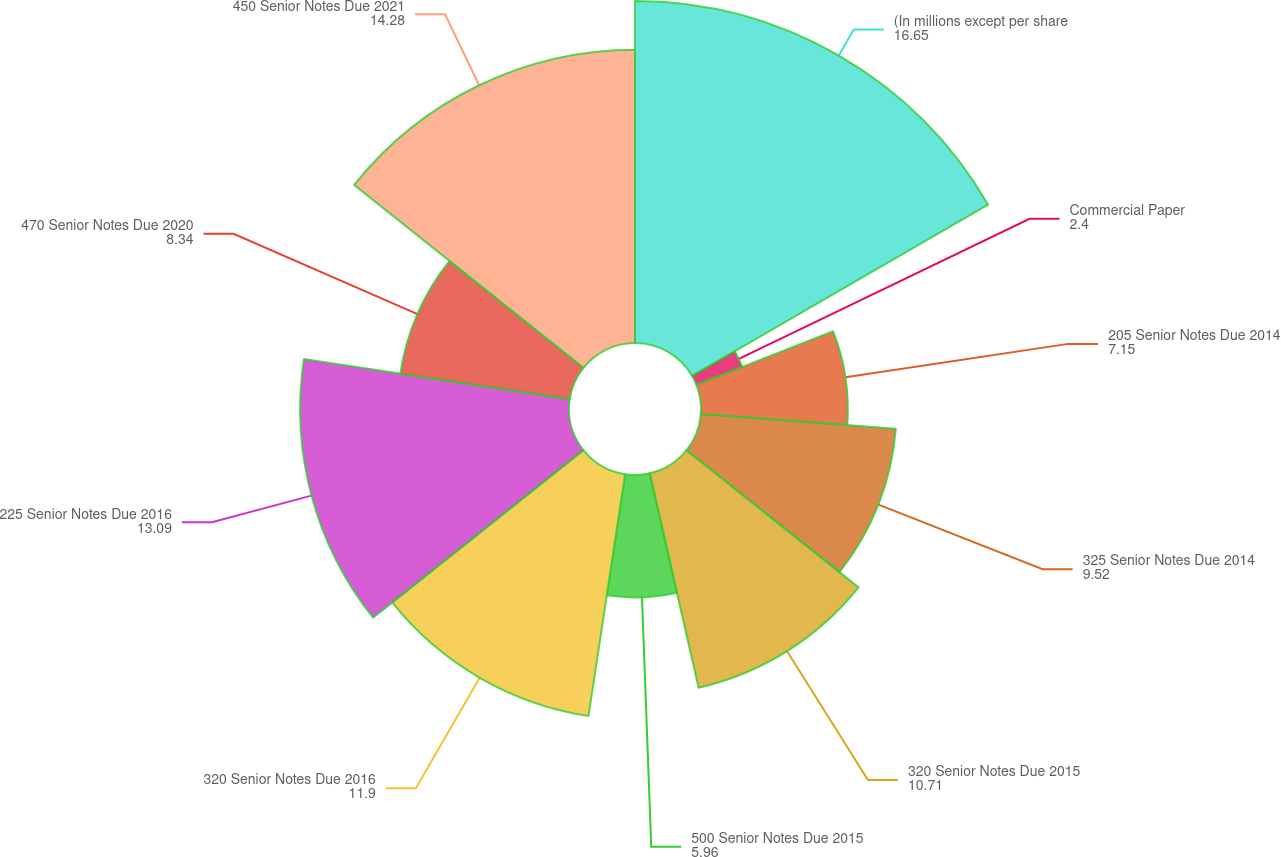<chart> <loc_0><loc_0><loc_500><loc_500><pie_chart><fcel>(In millions except per share<fcel>Commercial Paper<fcel>205 Senior Notes Due 2014<fcel>325 Senior Notes Due 2014<fcel>320 Senior Notes Due 2015<fcel>500 Senior Notes Due 2015<fcel>320 Senior Notes Due 2016<fcel>225 Senior Notes Due 2016<fcel>470 Senior Notes Due 2020<fcel>450 Senior Notes Due 2021<nl><fcel>16.65%<fcel>2.4%<fcel>7.15%<fcel>9.52%<fcel>10.71%<fcel>5.96%<fcel>11.9%<fcel>13.09%<fcel>8.34%<fcel>14.28%<nl></chart> 